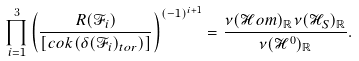Convert formula to latex. <formula><loc_0><loc_0><loc_500><loc_500>\prod _ { i = 1 } ^ { 3 } \left ( \frac { R ( \mathcal { F } _ { i } ) } { [ c o k ( \delta ( \mathcal { F } _ { i } ) _ { t o r } ) ] } \right ) ^ { ( - 1 ) ^ { i + 1 } } = \frac { \nu ( \mathcal { H } o m ) _ { \mathbb { R } } \nu ( \mathcal { H } _ { S } ) _ { \mathbb { R } } } { \nu ( \mathcal { H } ^ { 0 } ) _ { \mathbb { R } } } .</formula> 